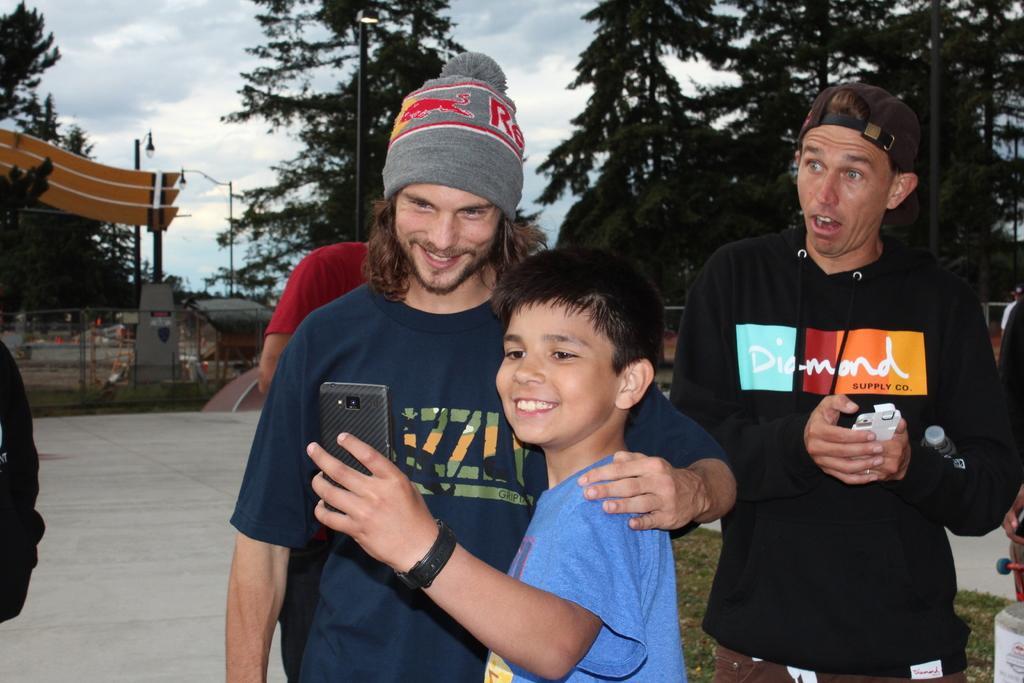Describe this image in one or two sentences. In the image we can see there is a kid taking selfie with a man, there are other people standing at the back. Behind there is a man standing and holding mobile phone and water bottle in his hand. There are lot of trees at the back. 